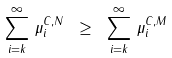<formula> <loc_0><loc_0><loc_500><loc_500>\sum _ { i = k } ^ { \infty } \, \mu ^ { C , N } _ { i } \ \geq \ \sum _ { i = k } ^ { \infty } \, \mu ^ { C , M } _ { i }</formula> 